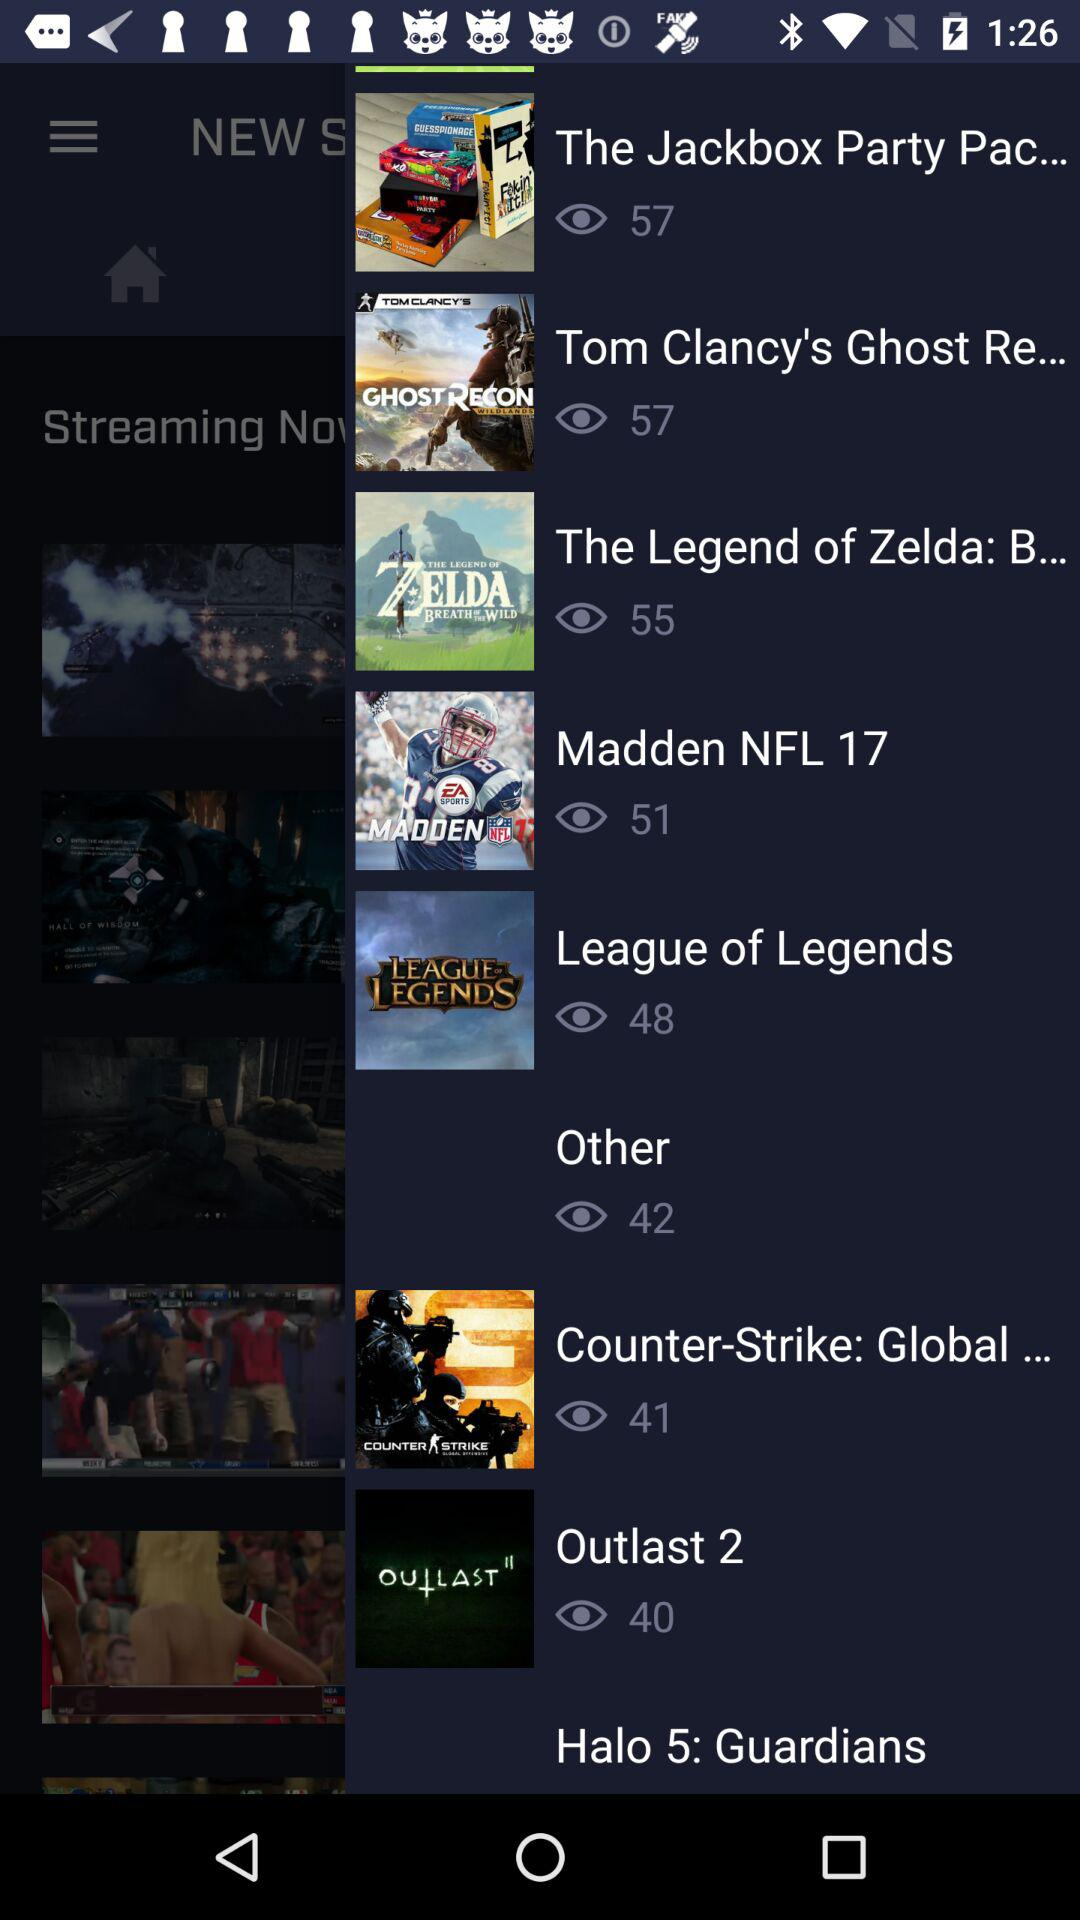How many people have watched League of Legends?
Answer the question using a single word or phrase. There are 48 people who have watched League of Legends 